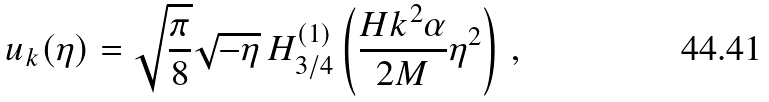<formula> <loc_0><loc_0><loc_500><loc_500>u _ { k } ( \eta ) = \sqrt { \frac { \pi } { 8 } } \sqrt { - \eta } \, H ^ { ( 1 ) } _ { 3 / 4 } \left ( \frac { H k ^ { 2 } \alpha } { 2 M } \eta ^ { 2 } \right ) \, ,</formula> 